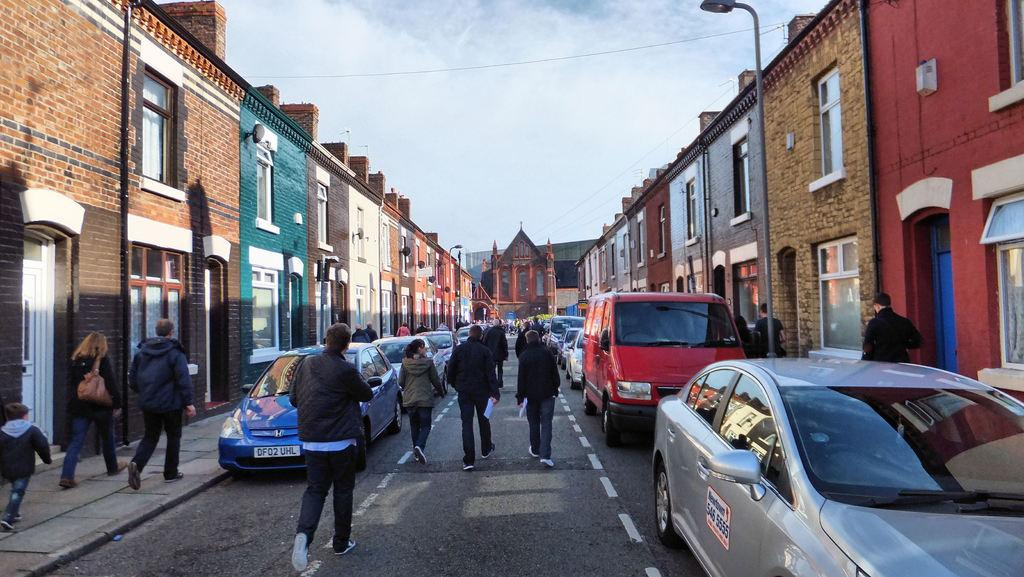What are the people in the image doing? The people in the image are walking on the road. What else can be seen on the road? There are vehicles on the road. What surrounds the road in the image? There are buildings on both sides of the road. Can you tell me how many blades are attached to the fireman's hat in the image? There is no fireman or hat with blades present in the image. 